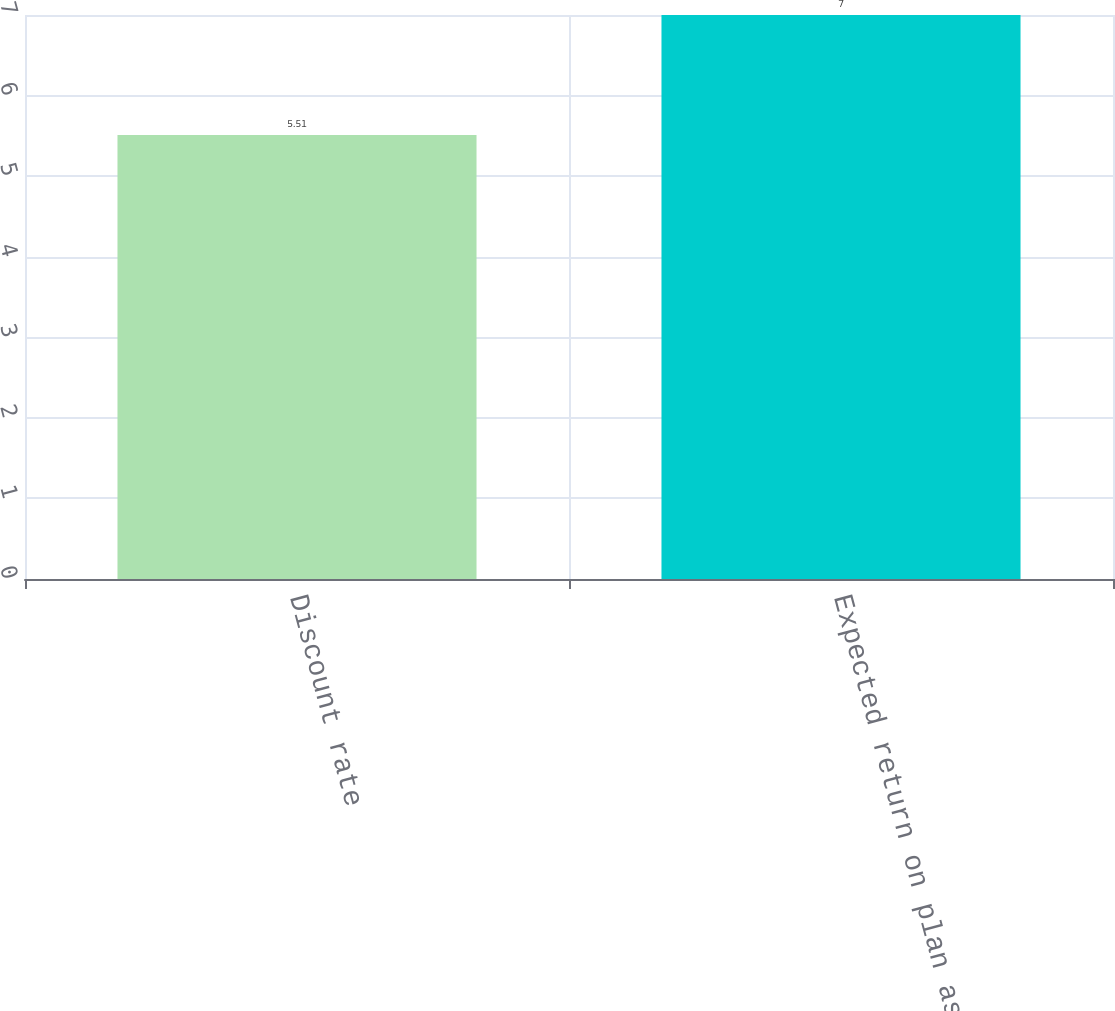Convert chart to OTSL. <chart><loc_0><loc_0><loc_500><loc_500><bar_chart><fcel>Discount rate<fcel>Expected return on plan assets<nl><fcel>5.51<fcel>7<nl></chart> 